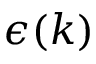<formula> <loc_0><loc_0><loc_500><loc_500>\epsilon ( k )</formula> 